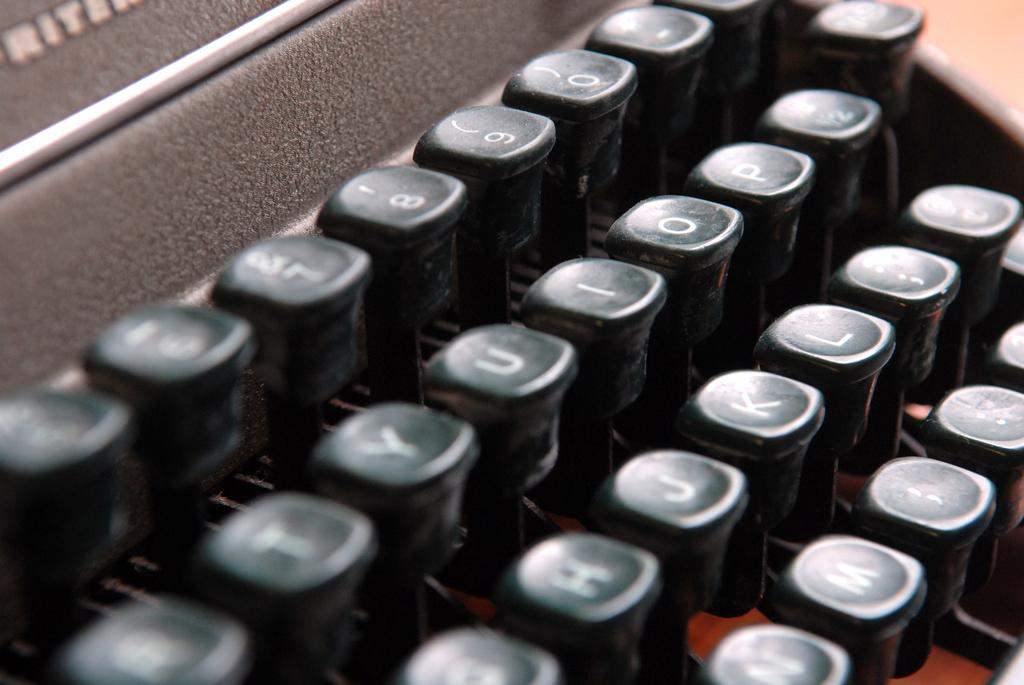What is the main object in the center of the image? There is a typewriter in the center of the image. What feature does the typewriter have? The typewriter has buttons. What is written on the buttons of the typewriter? The buttons have letters and numbers on them. What type of instrument is being played by the fireman in the image? There is no fireman or instrument present in the image. 